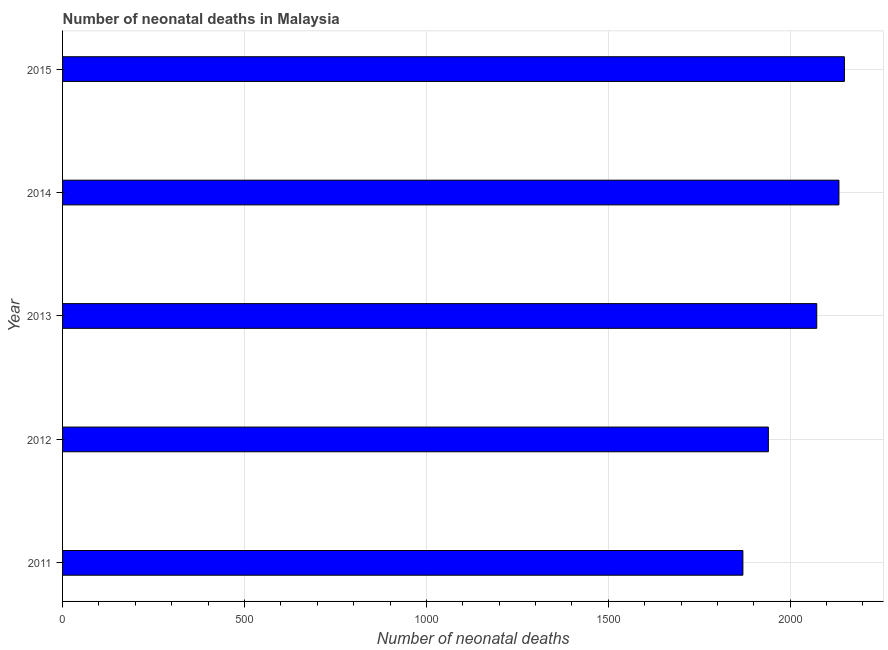Does the graph contain any zero values?
Give a very brief answer. No. Does the graph contain grids?
Ensure brevity in your answer.  Yes. What is the title of the graph?
Give a very brief answer. Number of neonatal deaths in Malaysia. What is the label or title of the X-axis?
Give a very brief answer. Number of neonatal deaths. What is the number of neonatal deaths in 2014?
Offer a terse response. 2134. Across all years, what is the maximum number of neonatal deaths?
Offer a terse response. 2149. Across all years, what is the minimum number of neonatal deaths?
Keep it short and to the point. 1870. In which year was the number of neonatal deaths maximum?
Make the answer very short. 2015. In which year was the number of neonatal deaths minimum?
Give a very brief answer. 2011. What is the sum of the number of neonatal deaths?
Give a very brief answer. 1.02e+04. What is the difference between the number of neonatal deaths in 2014 and 2015?
Your answer should be compact. -15. What is the average number of neonatal deaths per year?
Give a very brief answer. 2033. What is the median number of neonatal deaths?
Your answer should be compact. 2073. In how many years, is the number of neonatal deaths greater than 100 ?
Provide a succinct answer. 5. Do a majority of the years between 2013 and 2012 (inclusive) have number of neonatal deaths greater than 500 ?
Keep it short and to the point. No. What is the ratio of the number of neonatal deaths in 2011 to that in 2013?
Offer a very short reply. 0.9. Is the sum of the number of neonatal deaths in 2012 and 2014 greater than the maximum number of neonatal deaths across all years?
Provide a short and direct response. Yes. What is the difference between the highest and the lowest number of neonatal deaths?
Your response must be concise. 279. What is the Number of neonatal deaths of 2011?
Make the answer very short. 1870. What is the Number of neonatal deaths in 2012?
Offer a very short reply. 1940. What is the Number of neonatal deaths in 2013?
Your answer should be compact. 2073. What is the Number of neonatal deaths in 2014?
Your answer should be very brief. 2134. What is the Number of neonatal deaths in 2015?
Your answer should be very brief. 2149. What is the difference between the Number of neonatal deaths in 2011 and 2012?
Give a very brief answer. -70. What is the difference between the Number of neonatal deaths in 2011 and 2013?
Your response must be concise. -203. What is the difference between the Number of neonatal deaths in 2011 and 2014?
Keep it short and to the point. -264. What is the difference between the Number of neonatal deaths in 2011 and 2015?
Ensure brevity in your answer.  -279. What is the difference between the Number of neonatal deaths in 2012 and 2013?
Your response must be concise. -133. What is the difference between the Number of neonatal deaths in 2012 and 2014?
Make the answer very short. -194. What is the difference between the Number of neonatal deaths in 2012 and 2015?
Ensure brevity in your answer.  -209. What is the difference between the Number of neonatal deaths in 2013 and 2014?
Your response must be concise. -61. What is the difference between the Number of neonatal deaths in 2013 and 2015?
Your answer should be compact. -76. What is the difference between the Number of neonatal deaths in 2014 and 2015?
Your answer should be very brief. -15. What is the ratio of the Number of neonatal deaths in 2011 to that in 2012?
Keep it short and to the point. 0.96. What is the ratio of the Number of neonatal deaths in 2011 to that in 2013?
Ensure brevity in your answer.  0.9. What is the ratio of the Number of neonatal deaths in 2011 to that in 2014?
Your response must be concise. 0.88. What is the ratio of the Number of neonatal deaths in 2011 to that in 2015?
Provide a short and direct response. 0.87. What is the ratio of the Number of neonatal deaths in 2012 to that in 2013?
Your answer should be very brief. 0.94. What is the ratio of the Number of neonatal deaths in 2012 to that in 2014?
Give a very brief answer. 0.91. What is the ratio of the Number of neonatal deaths in 2012 to that in 2015?
Make the answer very short. 0.9. What is the ratio of the Number of neonatal deaths in 2013 to that in 2014?
Ensure brevity in your answer.  0.97. What is the ratio of the Number of neonatal deaths in 2013 to that in 2015?
Make the answer very short. 0.96. What is the ratio of the Number of neonatal deaths in 2014 to that in 2015?
Give a very brief answer. 0.99. 